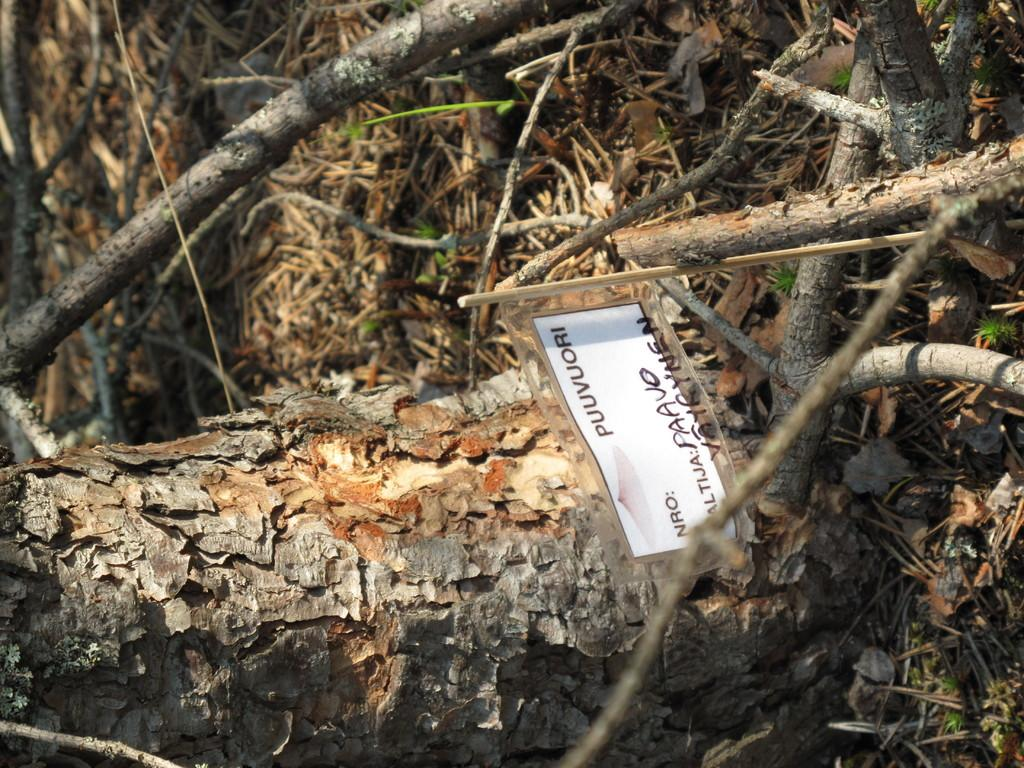What is attached to the wooden stick in the image? There is a paper attached to a wooden stick in the image. What can be seen in the background of the image? There is a tree trunk and tree branches visible in the background of the image. Is there a tiger hiding behind the tree trunk in the image? No, there is no tiger present in the image. 